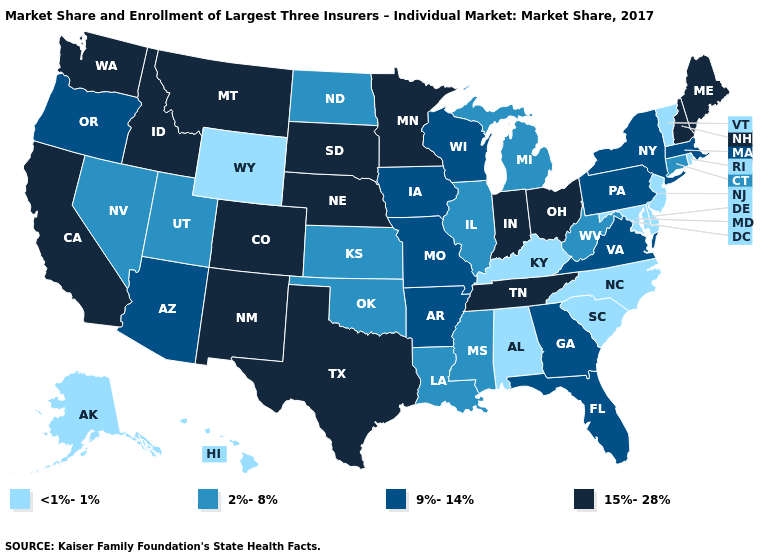Name the states that have a value in the range 2%-8%?
Concise answer only. Connecticut, Illinois, Kansas, Louisiana, Michigan, Mississippi, Nevada, North Dakota, Oklahoma, Utah, West Virginia. Which states hav the highest value in the South?
Short answer required. Tennessee, Texas. What is the lowest value in the USA?
Quick response, please. <1%-1%. Name the states that have a value in the range 15%-28%?
Answer briefly. California, Colorado, Idaho, Indiana, Maine, Minnesota, Montana, Nebraska, New Hampshire, New Mexico, Ohio, South Dakota, Tennessee, Texas, Washington. Name the states that have a value in the range <1%-1%?
Give a very brief answer. Alabama, Alaska, Delaware, Hawaii, Kentucky, Maryland, New Jersey, North Carolina, Rhode Island, South Carolina, Vermont, Wyoming. What is the highest value in states that border Missouri?
Short answer required. 15%-28%. What is the value of Idaho?
Give a very brief answer. 15%-28%. Name the states that have a value in the range 15%-28%?
Answer briefly. California, Colorado, Idaho, Indiana, Maine, Minnesota, Montana, Nebraska, New Hampshire, New Mexico, Ohio, South Dakota, Tennessee, Texas, Washington. Name the states that have a value in the range 2%-8%?
Short answer required. Connecticut, Illinois, Kansas, Louisiana, Michigan, Mississippi, Nevada, North Dakota, Oklahoma, Utah, West Virginia. Among the states that border Delaware , does Pennsylvania have the highest value?
Be succinct. Yes. What is the value of Kansas?
Give a very brief answer. 2%-8%. What is the value of Colorado?
Keep it brief. 15%-28%. What is the lowest value in the USA?
Short answer required. <1%-1%. How many symbols are there in the legend?
Short answer required. 4. Is the legend a continuous bar?
Short answer required. No. 